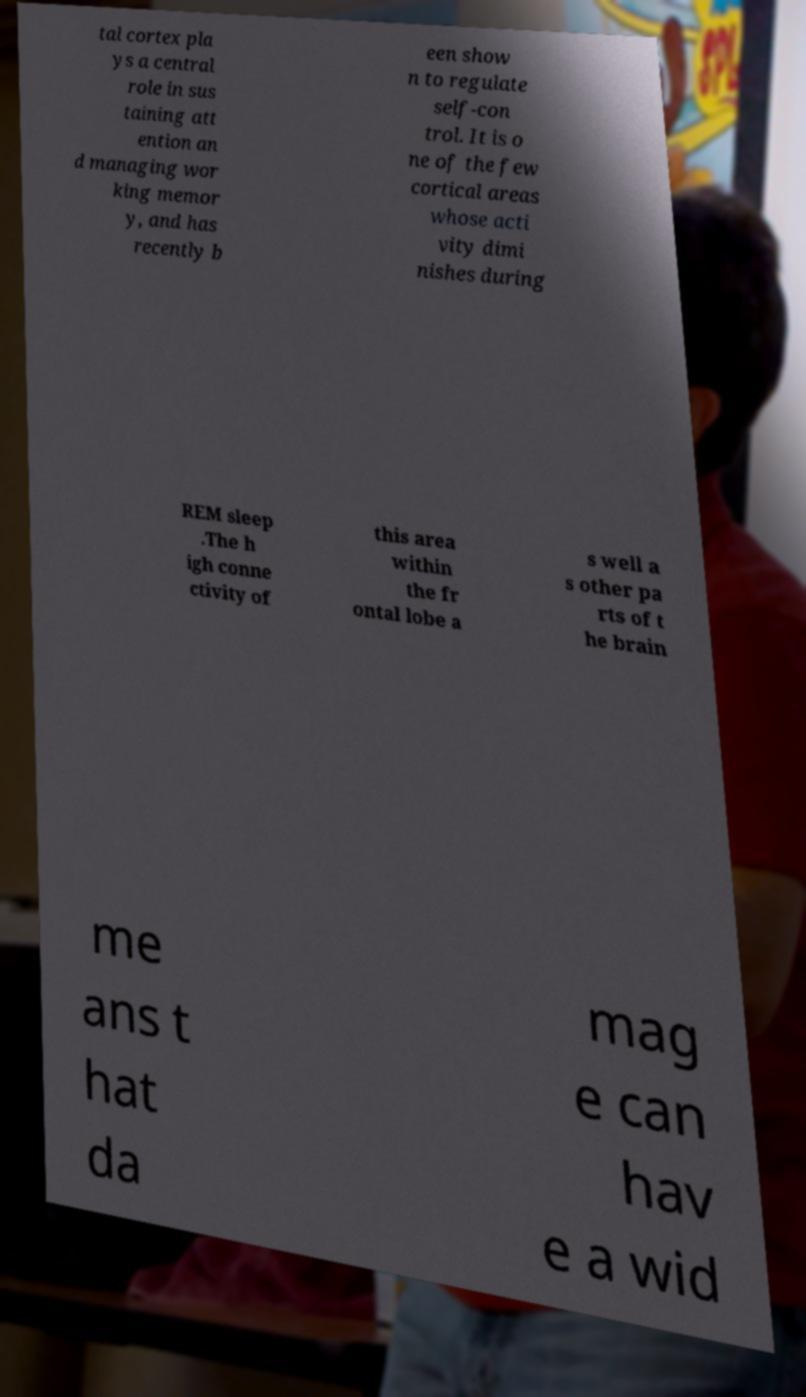Can you accurately transcribe the text from the provided image for me? tal cortex pla ys a central role in sus taining att ention an d managing wor king memor y, and has recently b een show n to regulate self-con trol. It is o ne of the few cortical areas whose acti vity dimi nishes during REM sleep .The h igh conne ctivity of this area within the fr ontal lobe a s well a s other pa rts of t he brain me ans t hat da mag e can hav e a wid 